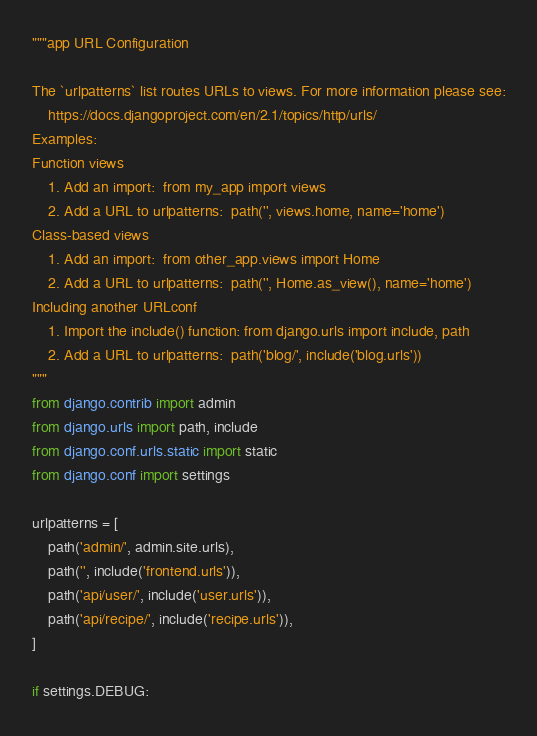<code> <loc_0><loc_0><loc_500><loc_500><_Python_>"""app URL Configuration

The `urlpatterns` list routes URLs to views. For more information please see:
    https://docs.djangoproject.com/en/2.1/topics/http/urls/
Examples:
Function views
    1. Add an import:  from my_app import views
    2. Add a URL to urlpatterns:  path('', views.home, name='home')
Class-based views
    1. Add an import:  from other_app.views import Home
    2. Add a URL to urlpatterns:  path('', Home.as_view(), name='home')
Including another URLconf
    1. Import the include() function: from django.urls import include, path
    2. Add a URL to urlpatterns:  path('blog/', include('blog.urls'))
"""
from django.contrib import admin
from django.urls import path, include
from django.conf.urls.static import static
from django.conf import settings

urlpatterns = [
    path('admin/', admin.site.urls),
    path('', include('frontend.urls')),
    path('api/user/', include('user.urls')),
    path('api/recipe/', include('recipe.urls')),
]

if settings.DEBUG:</code> 